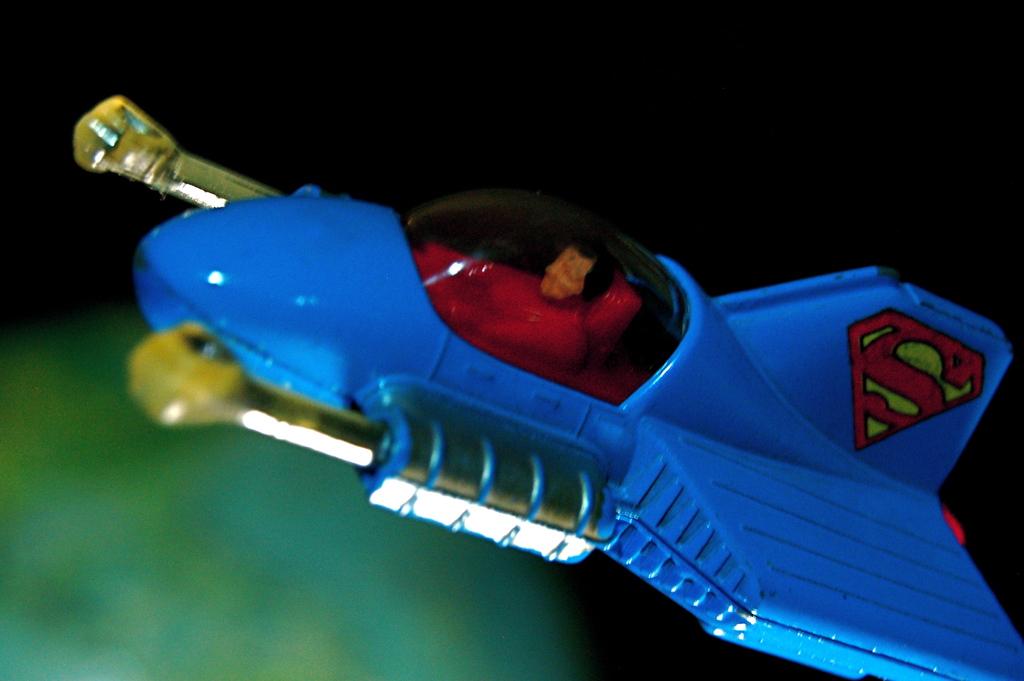Is this superman in his aircraft?
Offer a very short reply. Yes. This a toyata car?
Keep it short and to the point. No. 